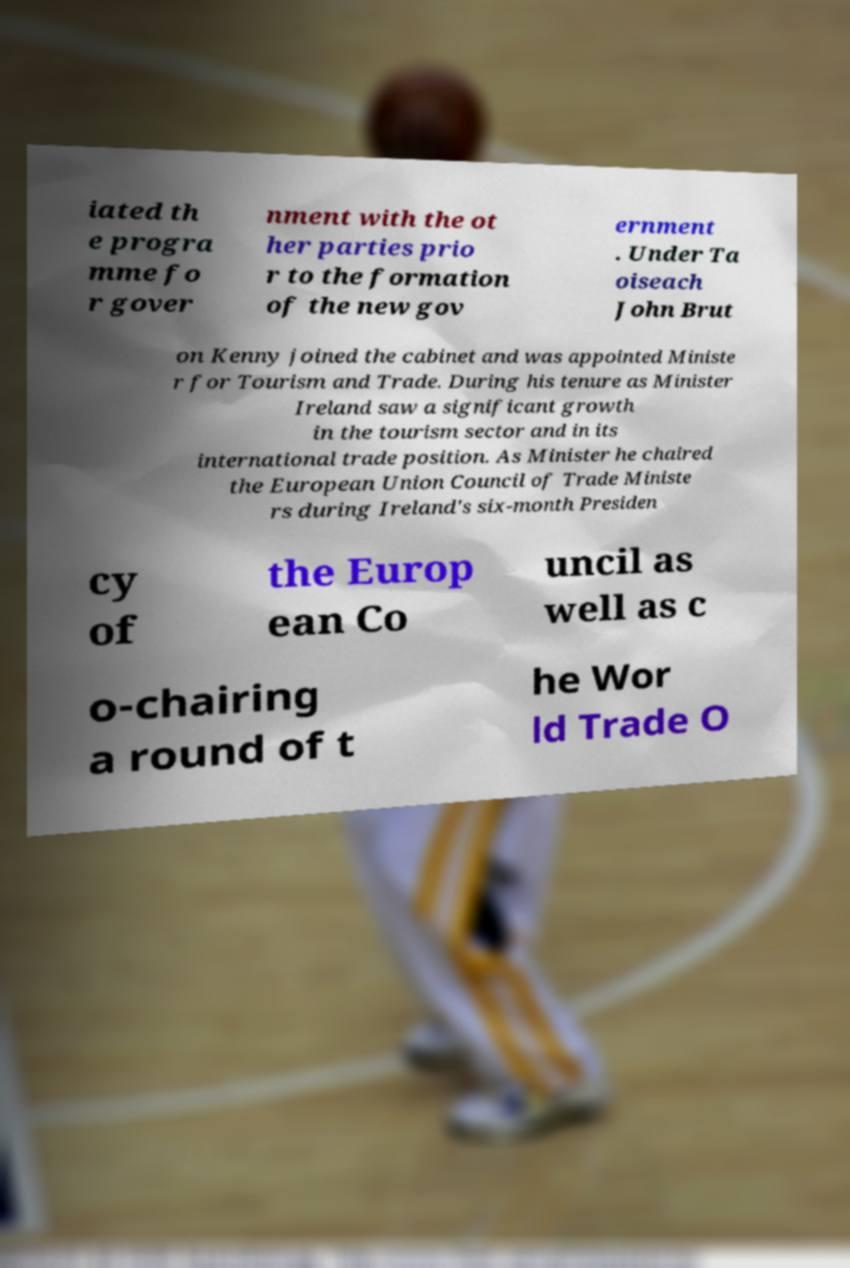There's text embedded in this image that I need extracted. Can you transcribe it verbatim? iated th e progra mme fo r gover nment with the ot her parties prio r to the formation of the new gov ernment . Under Ta oiseach John Brut on Kenny joined the cabinet and was appointed Ministe r for Tourism and Trade. During his tenure as Minister Ireland saw a significant growth in the tourism sector and in its international trade position. As Minister he chaired the European Union Council of Trade Ministe rs during Ireland's six-month Presiden cy of the Europ ean Co uncil as well as c o-chairing a round of t he Wor ld Trade O 